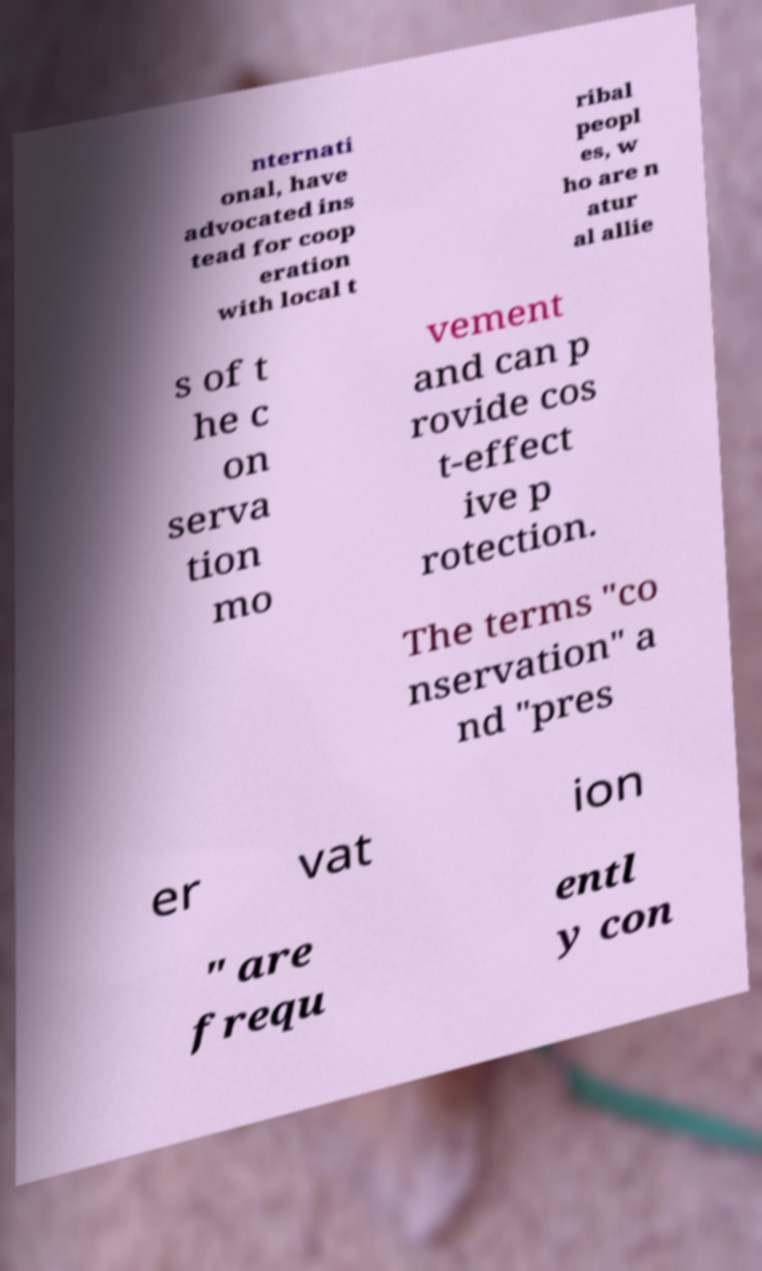I need the written content from this picture converted into text. Can you do that? nternati onal, have advocated ins tead for coop eration with local t ribal peopl es, w ho are n atur al allie s of t he c on serva tion mo vement and can p rovide cos t-effect ive p rotection. The terms "co nservation" a nd "pres er vat ion " are frequ entl y con 